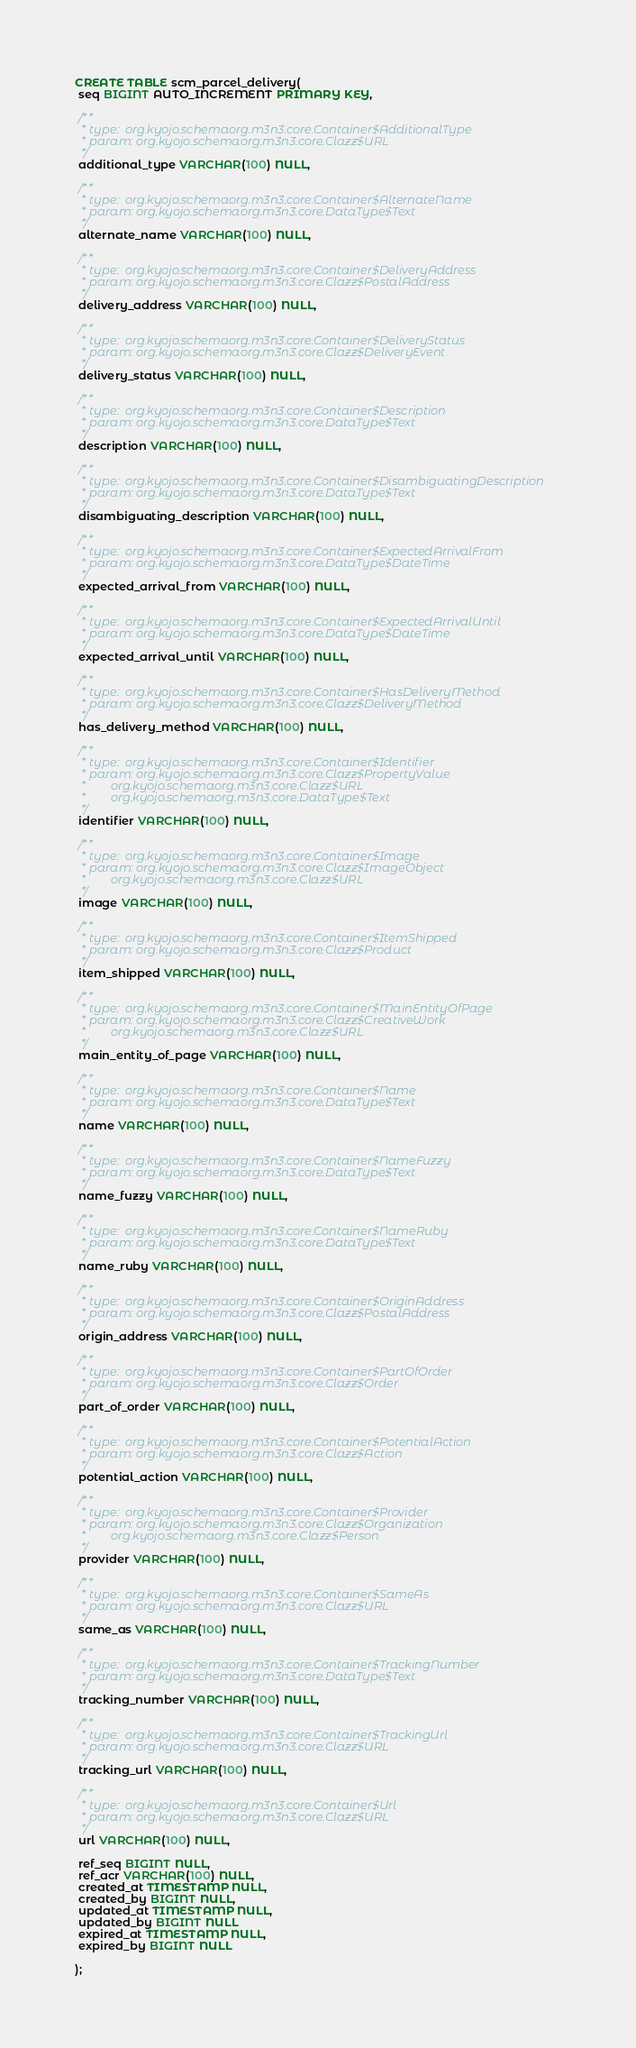<code> <loc_0><loc_0><loc_500><loc_500><_SQL_>CREATE TABLE scm_parcel_delivery(
 seq BIGINT AUTO_INCREMENT PRIMARY KEY,

 /**
  * type:  org.kyojo.schemaorg.m3n3.core.Container$AdditionalType
  * param: org.kyojo.schemaorg.m3n3.core.Clazz$URL
  */
 additional_type VARCHAR(100) NULL,

 /**
  * type:  org.kyojo.schemaorg.m3n3.core.Container$AlternateName
  * param: org.kyojo.schemaorg.m3n3.core.DataType$Text
  */
 alternate_name VARCHAR(100) NULL,

 /**
  * type:  org.kyojo.schemaorg.m3n3.core.Container$DeliveryAddress
  * param: org.kyojo.schemaorg.m3n3.core.Clazz$PostalAddress
  */
 delivery_address VARCHAR(100) NULL,

 /**
  * type:  org.kyojo.schemaorg.m3n3.core.Container$DeliveryStatus
  * param: org.kyojo.schemaorg.m3n3.core.Clazz$DeliveryEvent
  */
 delivery_status VARCHAR(100) NULL,

 /**
  * type:  org.kyojo.schemaorg.m3n3.core.Container$Description
  * param: org.kyojo.schemaorg.m3n3.core.DataType$Text
  */
 description VARCHAR(100) NULL,

 /**
  * type:  org.kyojo.schemaorg.m3n3.core.Container$DisambiguatingDescription
  * param: org.kyojo.schemaorg.m3n3.core.DataType$Text
  */
 disambiguating_description VARCHAR(100) NULL,

 /**
  * type:  org.kyojo.schemaorg.m3n3.core.Container$ExpectedArrivalFrom
  * param: org.kyojo.schemaorg.m3n3.core.DataType$DateTime
  */
 expected_arrival_from VARCHAR(100) NULL,

 /**
  * type:  org.kyojo.schemaorg.m3n3.core.Container$ExpectedArrivalUntil
  * param: org.kyojo.schemaorg.m3n3.core.DataType$DateTime
  */
 expected_arrival_until VARCHAR(100) NULL,

 /**
  * type:  org.kyojo.schemaorg.m3n3.core.Container$HasDeliveryMethod
  * param: org.kyojo.schemaorg.m3n3.core.Clazz$DeliveryMethod
  */
 has_delivery_method VARCHAR(100) NULL,

 /**
  * type:  org.kyojo.schemaorg.m3n3.core.Container$Identifier
  * param: org.kyojo.schemaorg.m3n3.core.Clazz$PropertyValue
  *        org.kyojo.schemaorg.m3n3.core.Clazz$URL
  *        org.kyojo.schemaorg.m3n3.core.DataType$Text
  */
 identifier VARCHAR(100) NULL,

 /**
  * type:  org.kyojo.schemaorg.m3n3.core.Container$Image
  * param: org.kyojo.schemaorg.m3n3.core.Clazz$ImageObject
  *        org.kyojo.schemaorg.m3n3.core.Clazz$URL
  */
 image VARCHAR(100) NULL,

 /**
  * type:  org.kyojo.schemaorg.m3n3.core.Container$ItemShipped
  * param: org.kyojo.schemaorg.m3n3.core.Clazz$Product
  */
 item_shipped VARCHAR(100) NULL,

 /**
  * type:  org.kyojo.schemaorg.m3n3.core.Container$MainEntityOfPage
  * param: org.kyojo.schemaorg.m3n3.core.Clazz$CreativeWork
  *        org.kyojo.schemaorg.m3n3.core.Clazz$URL
  */
 main_entity_of_page VARCHAR(100) NULL,

 /**
  * type:  org.kyojo.schemaorg.m3n3.core.Container$Name
  * param: org.kyojo.schemaorg.m3n3.core.DataType$Text
  */
 name VARCHAR(100) NULL,

 /**
  * type:  org.kyojo.schemaorg.m3n3.core.Container$NameFuzzy
  * param: org.kyojo.schemaorg.m3n3.core.DataType$Text
  */
 name_fuzzy VARCHAR(100) NULL,

 /**
  * type:  org.kyojo.schemaorg.m3n3.core.Container$NameRuby
  * param: org.kyojo.schemaorg.m3n3.core.DataType$Text
  */
 name_ruby VARCHAR(100) NULL,

 /**
  * type:  org.kyojo.schemaorg.m3n3.core.Container$OriginAddress
  * param: org.kyojo.schemaorg.m3n3.core.Clazz$PostalAddress
  */
 origin_address VARCHAR(100) NULL,

 /**
  * type:  org.kyojo.schemaorg.m3n3.core.Container$PartOfOrder
  * param: org.kyojo.schemaorg.m3n3.core.Clazz$Order
  */
 part_of_order VARCHAR(100) NULL,

 /**
  * type:  org.kyojo.schemaorg.m3n3.core.Container$PotentialAction
  * param: org.kyojo.schemaorg.m3n3.core.Clazz$Action
  */
 potential_action VARCHAR(100) NULL,

 /**
  * type:  org.kyojo.schemaorg.m3n3.core.Container$Provider
  * param: org.kyojo.schemaorg.m3n3.core.Clazz$Organization
  *        org.kyojo.schemaorg.m3n3.core.Clazz$Person
  */
 provider VARCHAR(100) NULL,

 /**
  * type:  org.kyojo.schemaorg.m3n3.core.Container$SameAs
  * param: org.kyojo.schemaorg.m3n3.core.Clazz$URL
  */
 same_as VARCHAR(100) NULL,

 /**
  * type:  org.kyojo.schemaorg.m3n3.core.Container$TrackingNumber
  * param: org.kyojo.schemaorg.m3n3.core.DataType$Text
  */
 tracking_number VARCHAR(100) NULL,

 /**
  * type:  org.kyojo.schemaorg.m3n3.core.Container$TrackingUrl
  * param: org.kyojo.schemaorg.m3n3.core.Clazz$URL
  */
 tracking_url VARCHAR(100) NULL,

 /**
  * type:  org.kyojo.schemaorg.m3n3.core.Container$Url
  * param: org.kyojo.schemaorg.m3n3.core.Clazz$URL
  */
 url VARCHAR(100) NULL,

 ref_seq BIGINT NULL,
 ref_acr VARCHAR(100) NULL,
 created_at TIMESTAMP NULL,
 created_by BIGINT NULL,
 updated_at TIMESTAMP NULL,
 updated_by BIGINT NULL
 expired_at TIMESTAMP NULL,
 expired_by BIGINT NULL

);</code> 